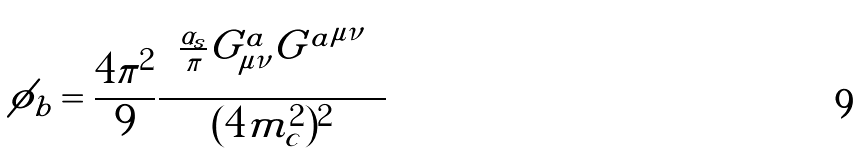<formula> <loc_0><loc_0><loc_500><loc_500>\phi _ { b } = \frac { 4 \pi ^ { 2 } } { 9 } \frac { \left \langle \frac { \alpha _ { s } } { \pi } G ^ { a } _ { \mu \nu } { G ^ { a } } ^ { \mu \nu } \right \rangle } { ( 4 m _ { c } ^ { 2 } ) ^ { 2 } }</formula> 